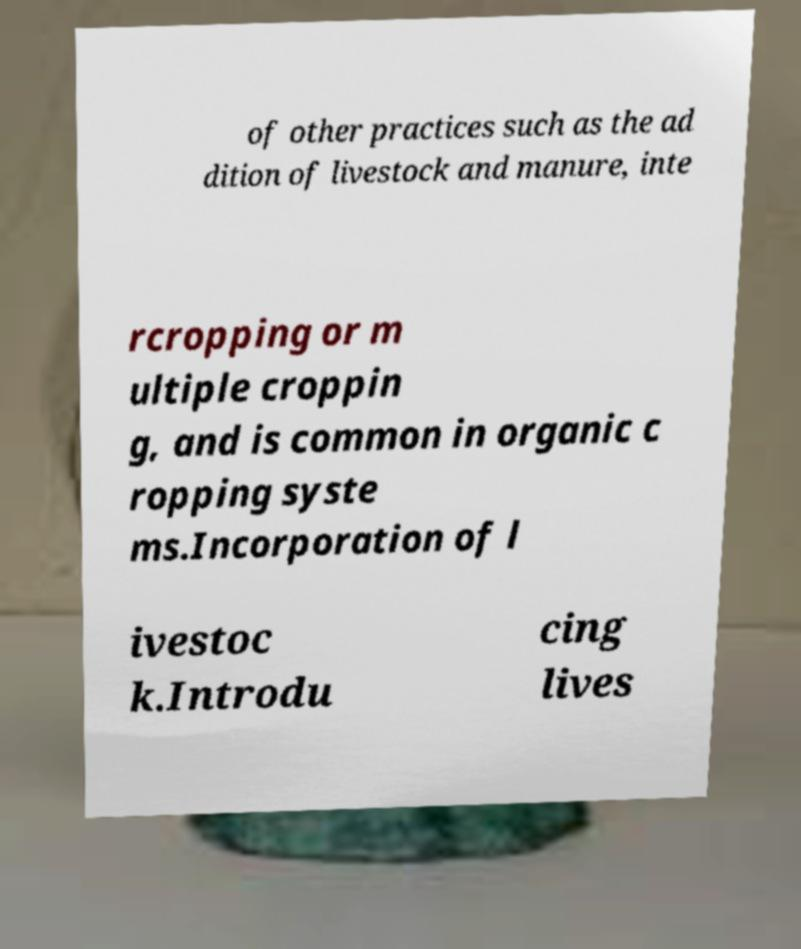What messages or text are displayed in this image? I need them in a readable, typed format. of other practices such as the ad dition of livestock and manure, inte rcropping or m ultiple croppin g, and is common in organic c ropping syste ms.Incorporation of l ivestoc k.Introdu cing lives 